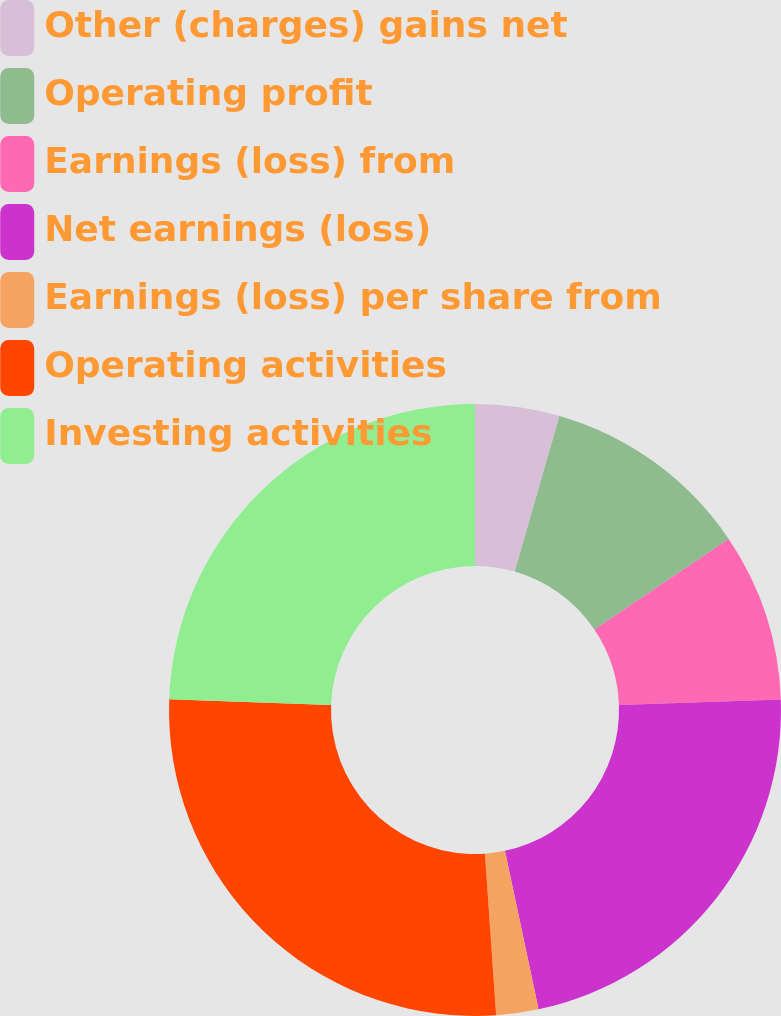<chart> <loc_0><loc_0><loc_500><loc_500><pie_chart><fcel>Other (charges) gains net<fcel>Operating profit<fcel>Earnings (loss) from<fcel>Net earnings (loss)<fcel>Earnings (loss) per share from<fcel>Operating activities<fcel>Investing activities<nl><fcel>4.45%<fcel>11.11%<fcel>8.89%<fcel>22.22%<fcel>2.23%<fcel>26.66%<fcel>24.44%<nl></chart> 